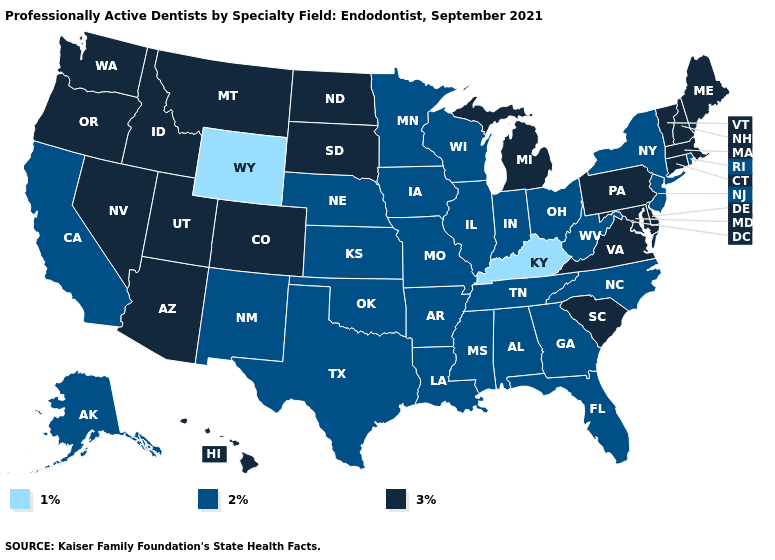Among the states that border Oklahoma , does Missouri have the highest value?
Answer briefly. No. Among the states that border Montana , does North Dakota have the lowest value?
Concise answer only. No. What is the value of Alaska?
Quick response, please. 2%. Which states have the lowest value in the USA?
Write a very short answer. Kentucky, Wyoming. What is the highest value in the Northeast ?
Give a very brief answer. 3%. Which states have the lowest value in the USA?
Give a very brief answer. Kentucky, Wyoming. Does Kansas have the highest value in the MidWest?
Give a very brief answer. No. Among the states that border Arkansas , which have the highest value?
Quick response, please. Louisiana, Mississippi, Missouri, Oklahoma, Tennessee, Texas. What is the value of Colorado?
Quick response, please. 3%. What is the highest value in states that border Mississippi?
Be succinct. 2%. What is the value of Arizona?
Keep it brief. 3%. Does the map have missing data?
Write a very short answer. No. 